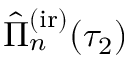Convert formula to latex. <formula><loc_0><loc_0><loc_500><loc_500>\hat { \Pi } _ { n } ^ { ( i r ) } ( \tau _ { 2 } )</formula> 